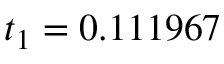Convert formula to latex. <formula><loc_0><loc_0><loc_500><loc_500>t _ { 1 } = 0 . 1 1 1 9 6 7</formula> 